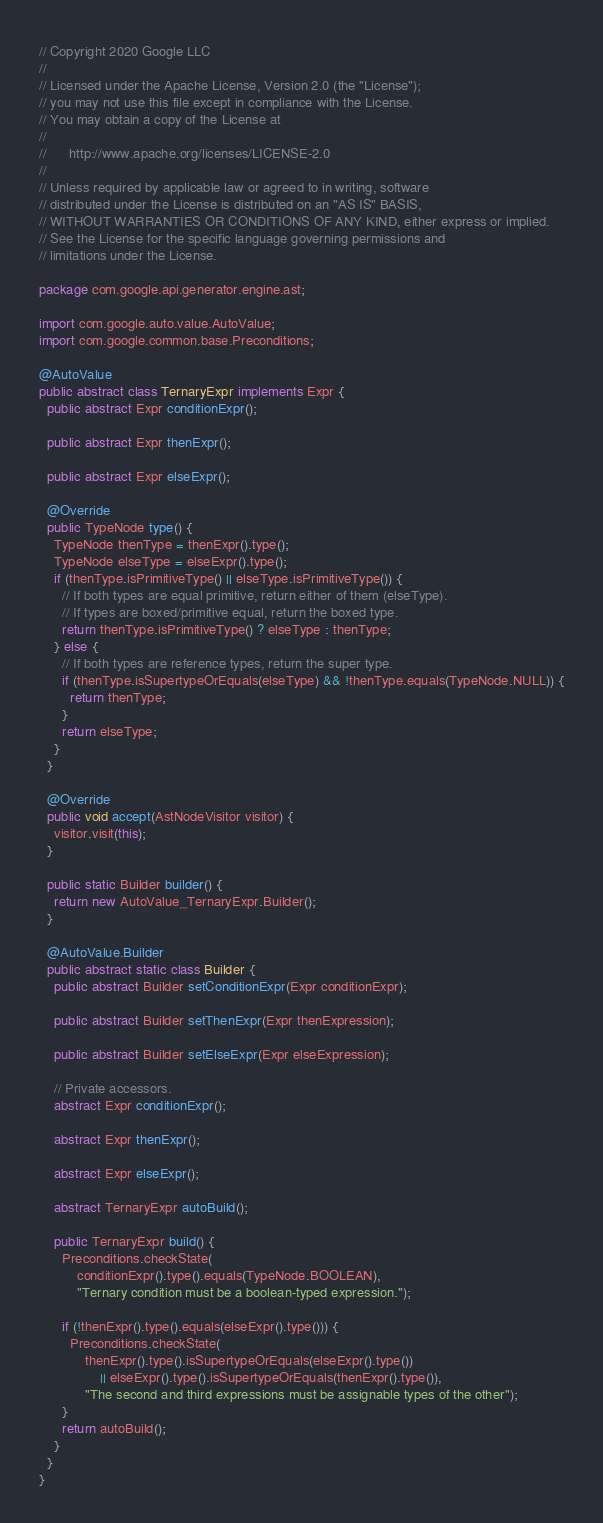<code> <loc_0><loc_0><loc_500><loc_500><_Java_>// Copyright 2020 Google LLC
//
// Licensed under the Apache License, Version 2.0 (the "License");
// you may not use this file except in compliance with the License.
// You may obtain a copy of the License at
//
//      http://www.apache.org/licenses/LICENSE-2.0
//
// Unless required by applicable law or agreed to in writing, software
// distributed under the License is distributed on an "AS IS" BASIS,
// WITHOUT WARRANTIES OR CONDITIONS OF ANY KIND, either express or implied.
// See the License for the specific language governing permissions and
// limitations under the License.

package com.google.api.generator.engine.ast;

import com.google.auto.value.AutoValue;
import com.google.common.base.Preconditions;

@AutoValue
public abstract class TernaryExpr implements Expr {
  public abstract Expr conditionExpr();

  public abstract Expr thenExpr();

  public abstract Expr elseExpr();

  @Override
  public TypeNode type() {
    TypeNode thenType = thenExpr().type();
    TypeNode elseType = elseExpr().type();
    if (thenType.isPrimitiveType() || elseType.isPrimitiveType()) {
      // If both types are equal primitive, return either of them (elseType).
      // If types are boxed/primitive equal, return the boxed type.
      return thenType.isPrimitiveType() ? elseType : thenType;
    } else {
      // If both types are reference types, return the super type.
      if (thenType.isSupertypeOrEquals(elseType) && !thenType.equals(TypeNode.NULL)) {
        return thenType;
      }
      return elseType;
    }
  }

  @Override
  public void accept(AstNodeVisitor visitor) {
    visitor.visit(this);
  }

  public static Builder builder() {
    return new AutoValue_TernaryExpr.Builder();
  }

  @AutoValue.Builder
  public abstract static class Builder {
    public abstract Builder setConditionExpr(Expr conditionExpr);

    public abstract Builder setThenExpr(Expr thenExpression);

    public abstract Builder setElseExpr(Expr elseExpression);

    // Private accessors.
    abstract Expr conditionExpr();

    abstract Expr thenExpr();

    abstract Expr elseExpr();

    abstract TernaryExpr autoBuild();

    public TernaryExpr build() {
      Preconditions.checkState(
          conditionExpr().type().equals(TypeNode.BOOLEAN),
          "Ternary condition must be a boolean-typed expression.");

      if (!thenExpr().type().equals(elseExpr().type())) {
        Preconditions.checkState(
            thenExpr().type().isSupertypeOrEquals(elseExpr().type())
                || elseExpr().type().isSupertypeOrEquals(thenExpr().type()),
            "The second and third expressions must be assignable types of the other");
      }
      return autoBuild();
    }
  }
}
</code> 